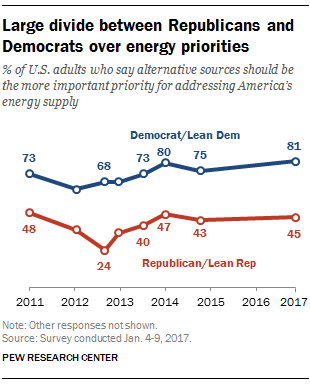Outline some significant characteristics in this image. In 2011, there was the smallest difference in opinion between the two groups. 